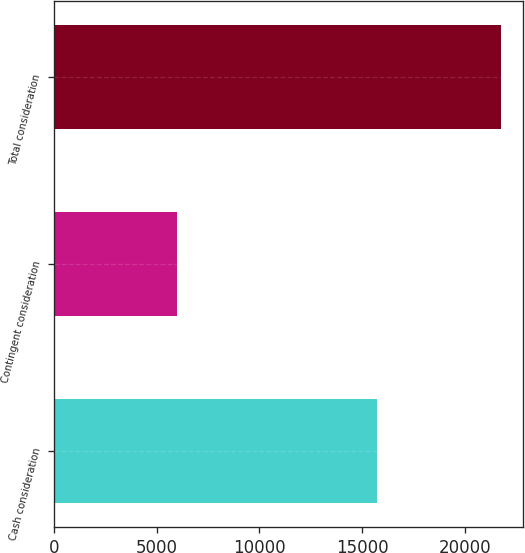Convert chart. <chart><loc_0><loc_0><loc_500><loc_500><bar_chart><fcel>Cash consideration<fcel>Contingent consideration<fcel>Total consideration<nl><fcel>15750<fcel>6000<fcel>21750<nl></chart> 